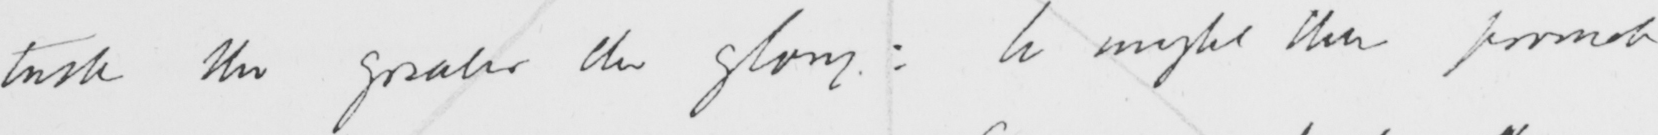Please transcribe the handwritten text in this image. task the greater the glory :  he might then promote 